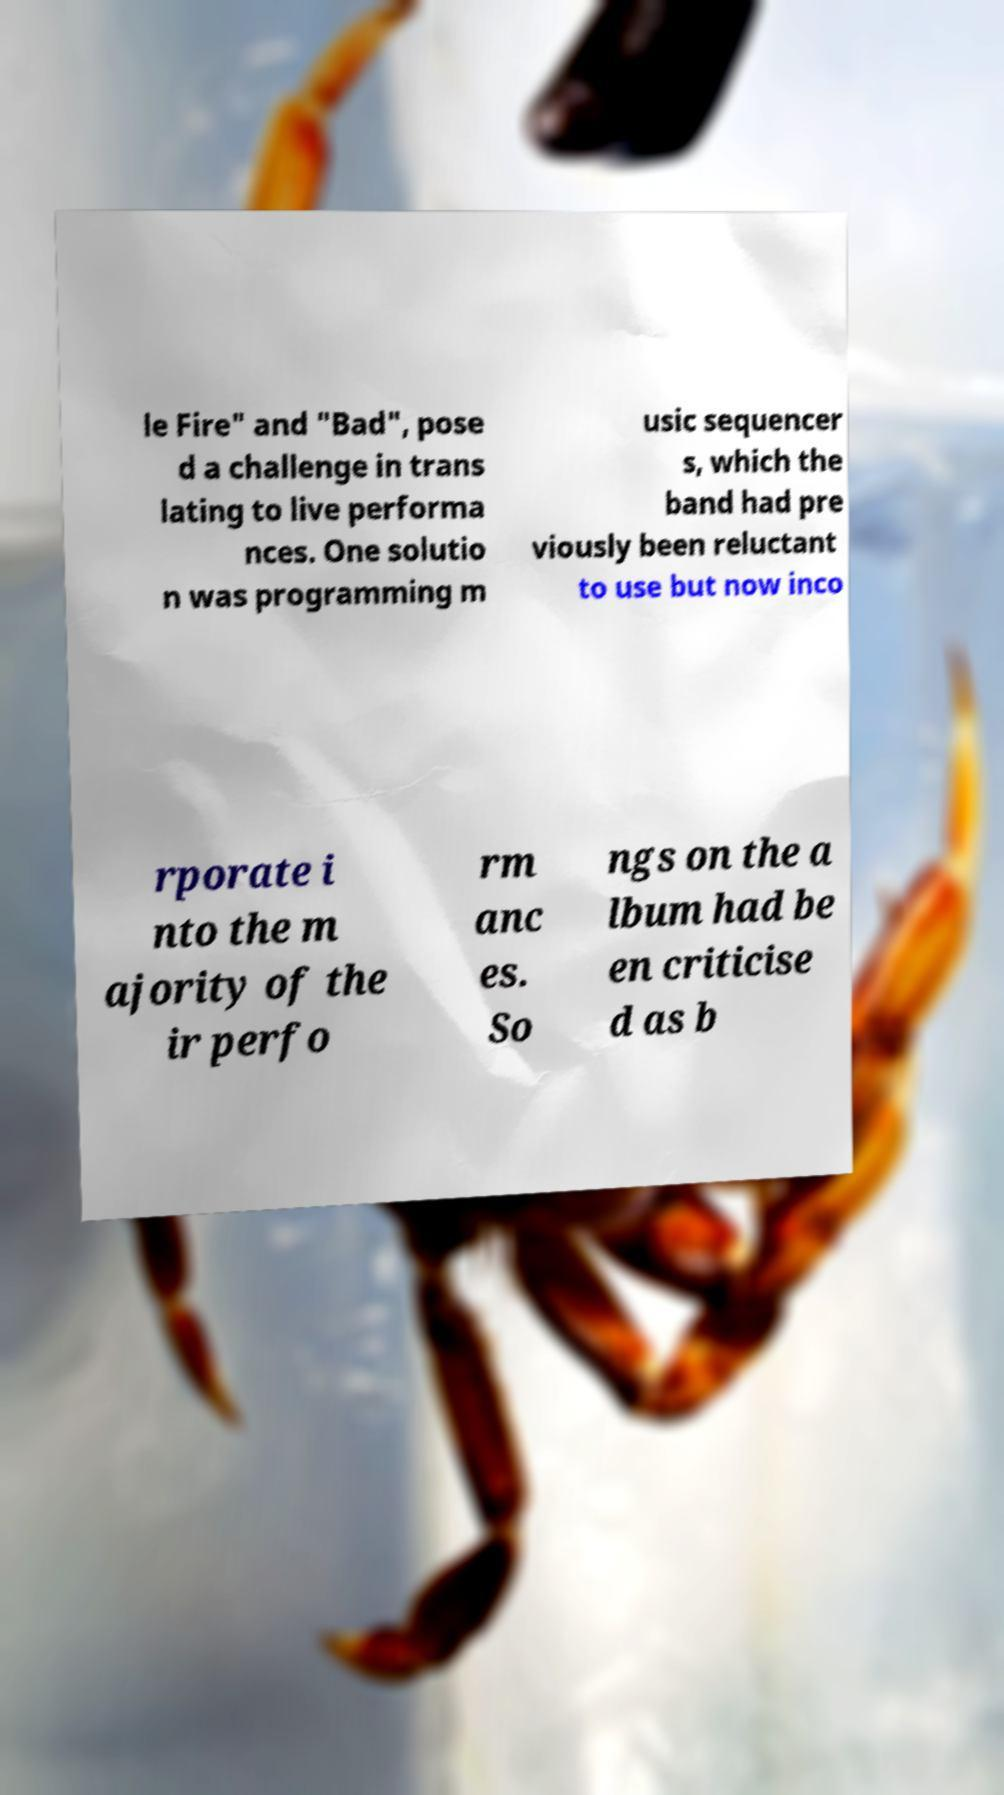Please identify and transcribe the text found in this image. le Fire" and "Bad", pose d a challenge in trans lating to live performa nces. One solutio n was programming m usic sequencer s, which the band had pre viously been reluctant to use but now inco rporate i nto the m ajority of the ir perfo rm anc es. So ngs on the a lbum had be en criticise d as b 